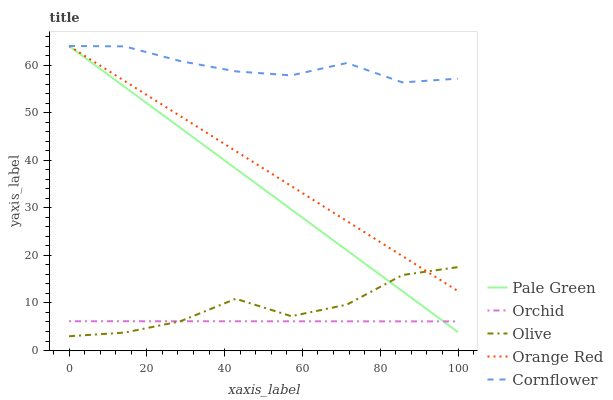Does Orchid have the minimum area under the curve?
Answer yes or no. Yes. Does Cornflower have the maximum area under the curve?
Answer yes or no. Yes. Does Pale Green have the minimum area under the curve?
Answer yes or no. No. Does Pale Green have the maximum area under the curve?
Answer yes or no. No. Is Pale Green the smoothest?
Answer yes or no. Yes. Is Olive the roughest?
Answer yes or no. Yes. Is Cornflower the smoothest?
Answer yes or no. No. Is Cornflower the roughest?
Answer yes or no. No. Does Olive have the lowest value?
Answer yes or no. Yes. Does Pale Green have the lowest value?
Answer yes or no. No. Does Orange Red have the highest value?
Answer yes or no. Yes. Does Orchid have the highest value?
Answer yes or no. No. Is Olive less than Cornflower?
Answer yes or no. Yes. Is Orange Red greater than Orchid?
Answer yes or no. Yes. Does Olive intersect Pale Green?
Answer yes or no. Yes. Is Olive less than Pale Green?
Answer yes or no. No. Is Olive greater than Pale Green?
Answer yes or no. No. Does Olive intersect Cornflower?
Answer yes or no. No. 